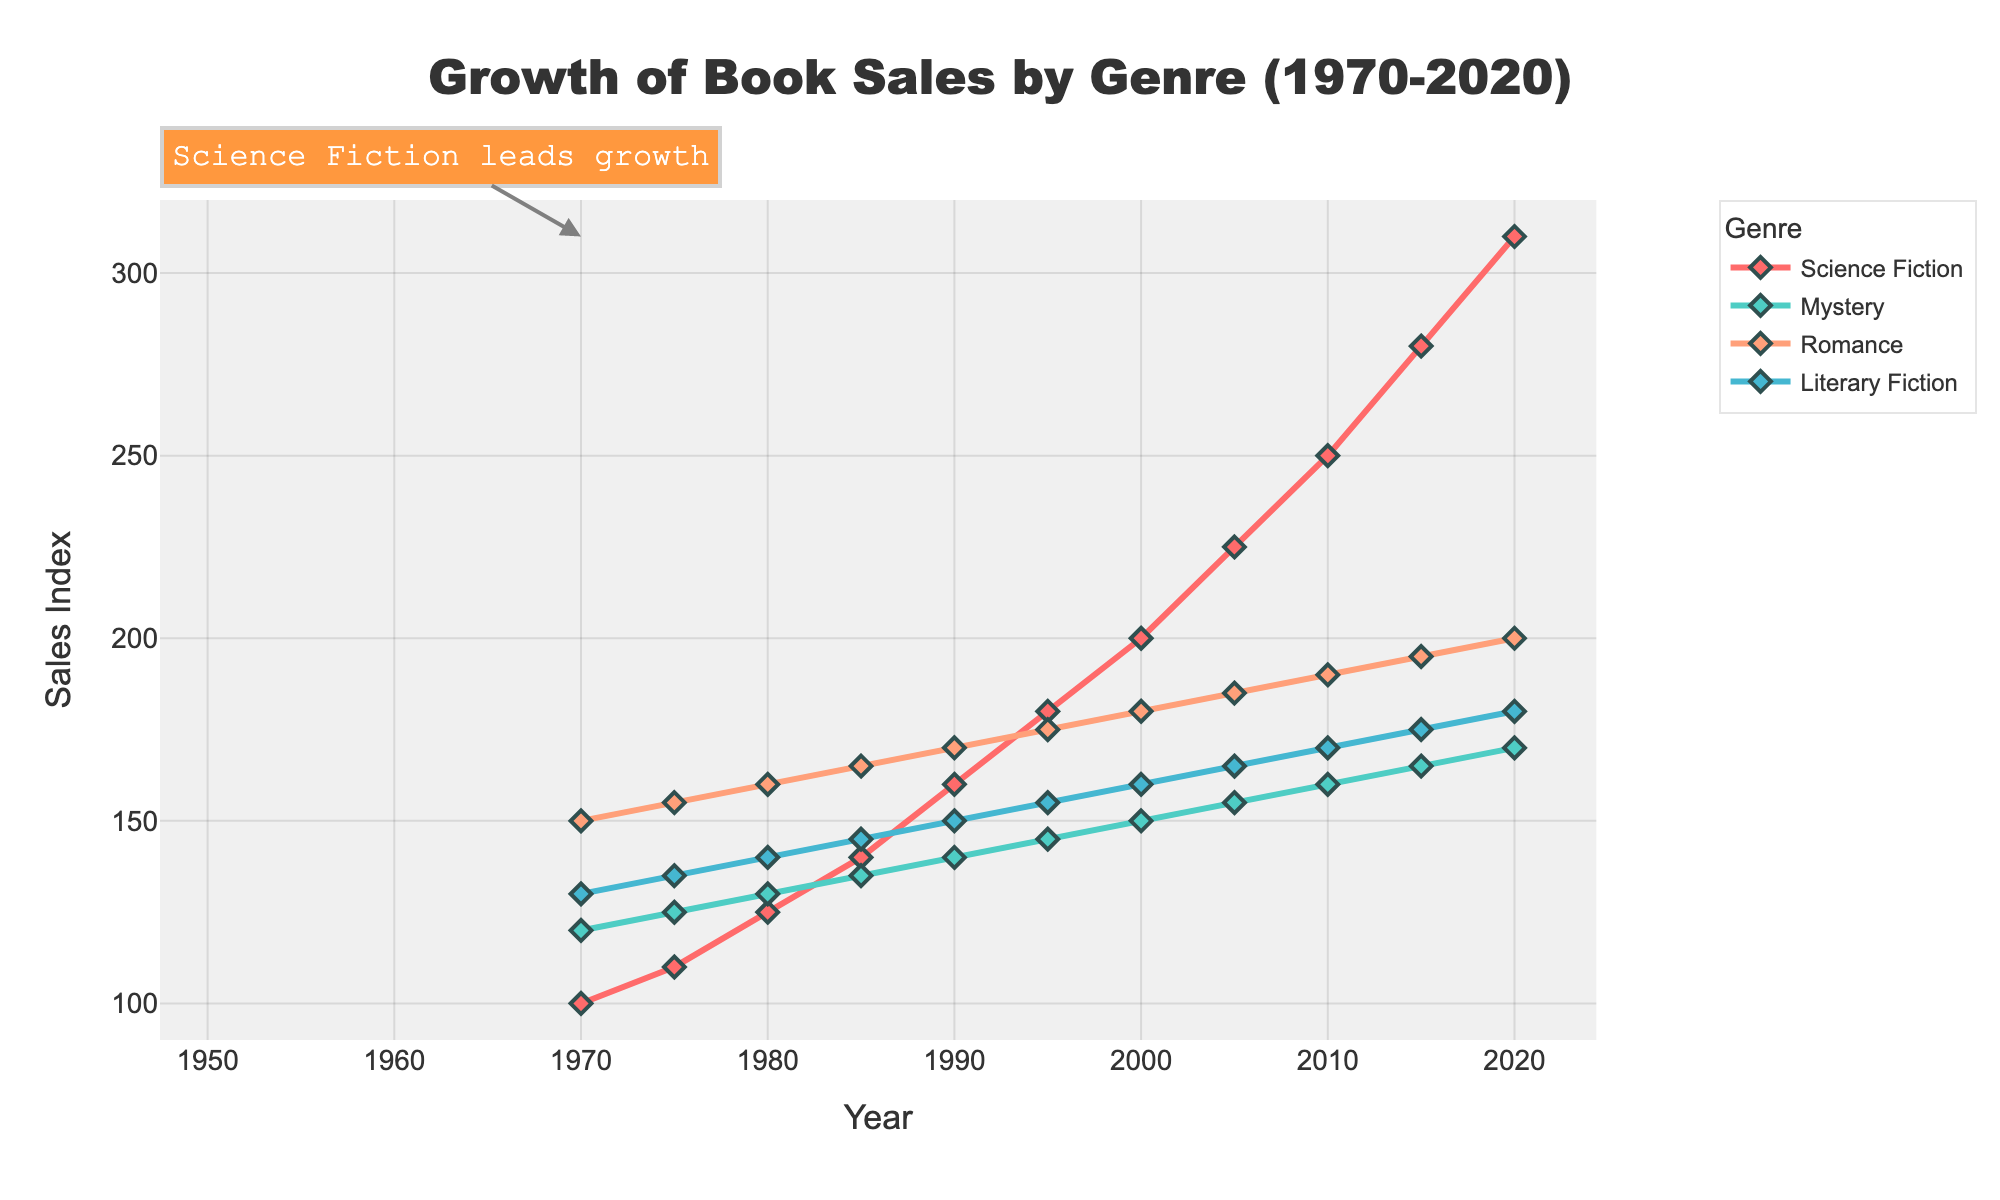what two genres show a rising trend in sales larger than Literary Fiction between 1970 and 2020? First, observe the overall trends for the genres. Science Fiction and Romance both exhibit higher increases in sales compared to Literary Fiction, starting from their respective points in 1970 and ending at higher values by 2020.
Answer: Science Fiction and Romance Between which years did the Mystery genre see its most significant increase in sales? Inspect the Mystery genre line. The biggest increase occurs between 2015 and 2020, going from 165 to 170.
Answer: 2015 to 2020 By how much did the sales index for Romance increase from 1970 to 2020? First, note the values for Romance in 1970 (150) and in 2020 (200). The difference is 200 - 150.
Answer: 50 Which genre consistently had the lowest sales index until 2020? Compare the lines for each genre year by year until 2020. Mystery consistently maintains the lowest sales index compared to others.
Answer: Mystery What is the approximate average growth in sales index per decade for Science Fiction between 1970 and 2020? To find the average growth per decade, note the increase from 1970 (100) to 2020 (310), which is 210. Divide this by 5 decades: 210/5.
Answer: 42 In what years did Literary Fiction have an equal sales index to Romance? Check the points where the lines for Literary Fiction and Romance meet. This occurs in 1980, 1985, and 1990.
Answer: 1980, 1985, 1990 Which genre shows the smallest increase in sales between 1970 and 2020? Calculate the total increase for each genre. Mystery starts at 120 and ends at 170, an increase of 50. This is the smallest increase compared to the others.
Answer: Mystery Compare the overall trend in sales index between 2000 and 2020 for Science Fiction and Romance. Which genre showed higher growth? For Science Fiction, sales index increased from 200 to 310, a growth of 110. For Romance, it increased from 180 to 200, a growth of 20.
Answer: Science Fiction Which genre has a visual attribute associated with the color blue in the figure? Inspect the color mappings for each genre. Literary Fiction is associated with the blue color.
Answer: Literary Fiction In what decade did Science Fiction sales start to surpass those of all other genres? Examine the points where Science Fiction surpasses the other genres. This occurs around the 1980s.
Answer: 1980s 